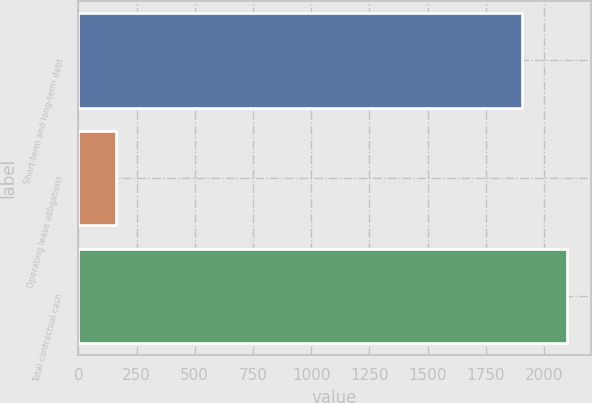Convert chart to OTSL. <chart><loc_0><loc_0><loc_500><loc_500><bar_chart><fcel>Short-term and long-term debt<fcel>Operating lease obligations<fcel>Total contractual cash<nl><fcel>1906<fcel>162<fcel>2096.6<nl></chart> 